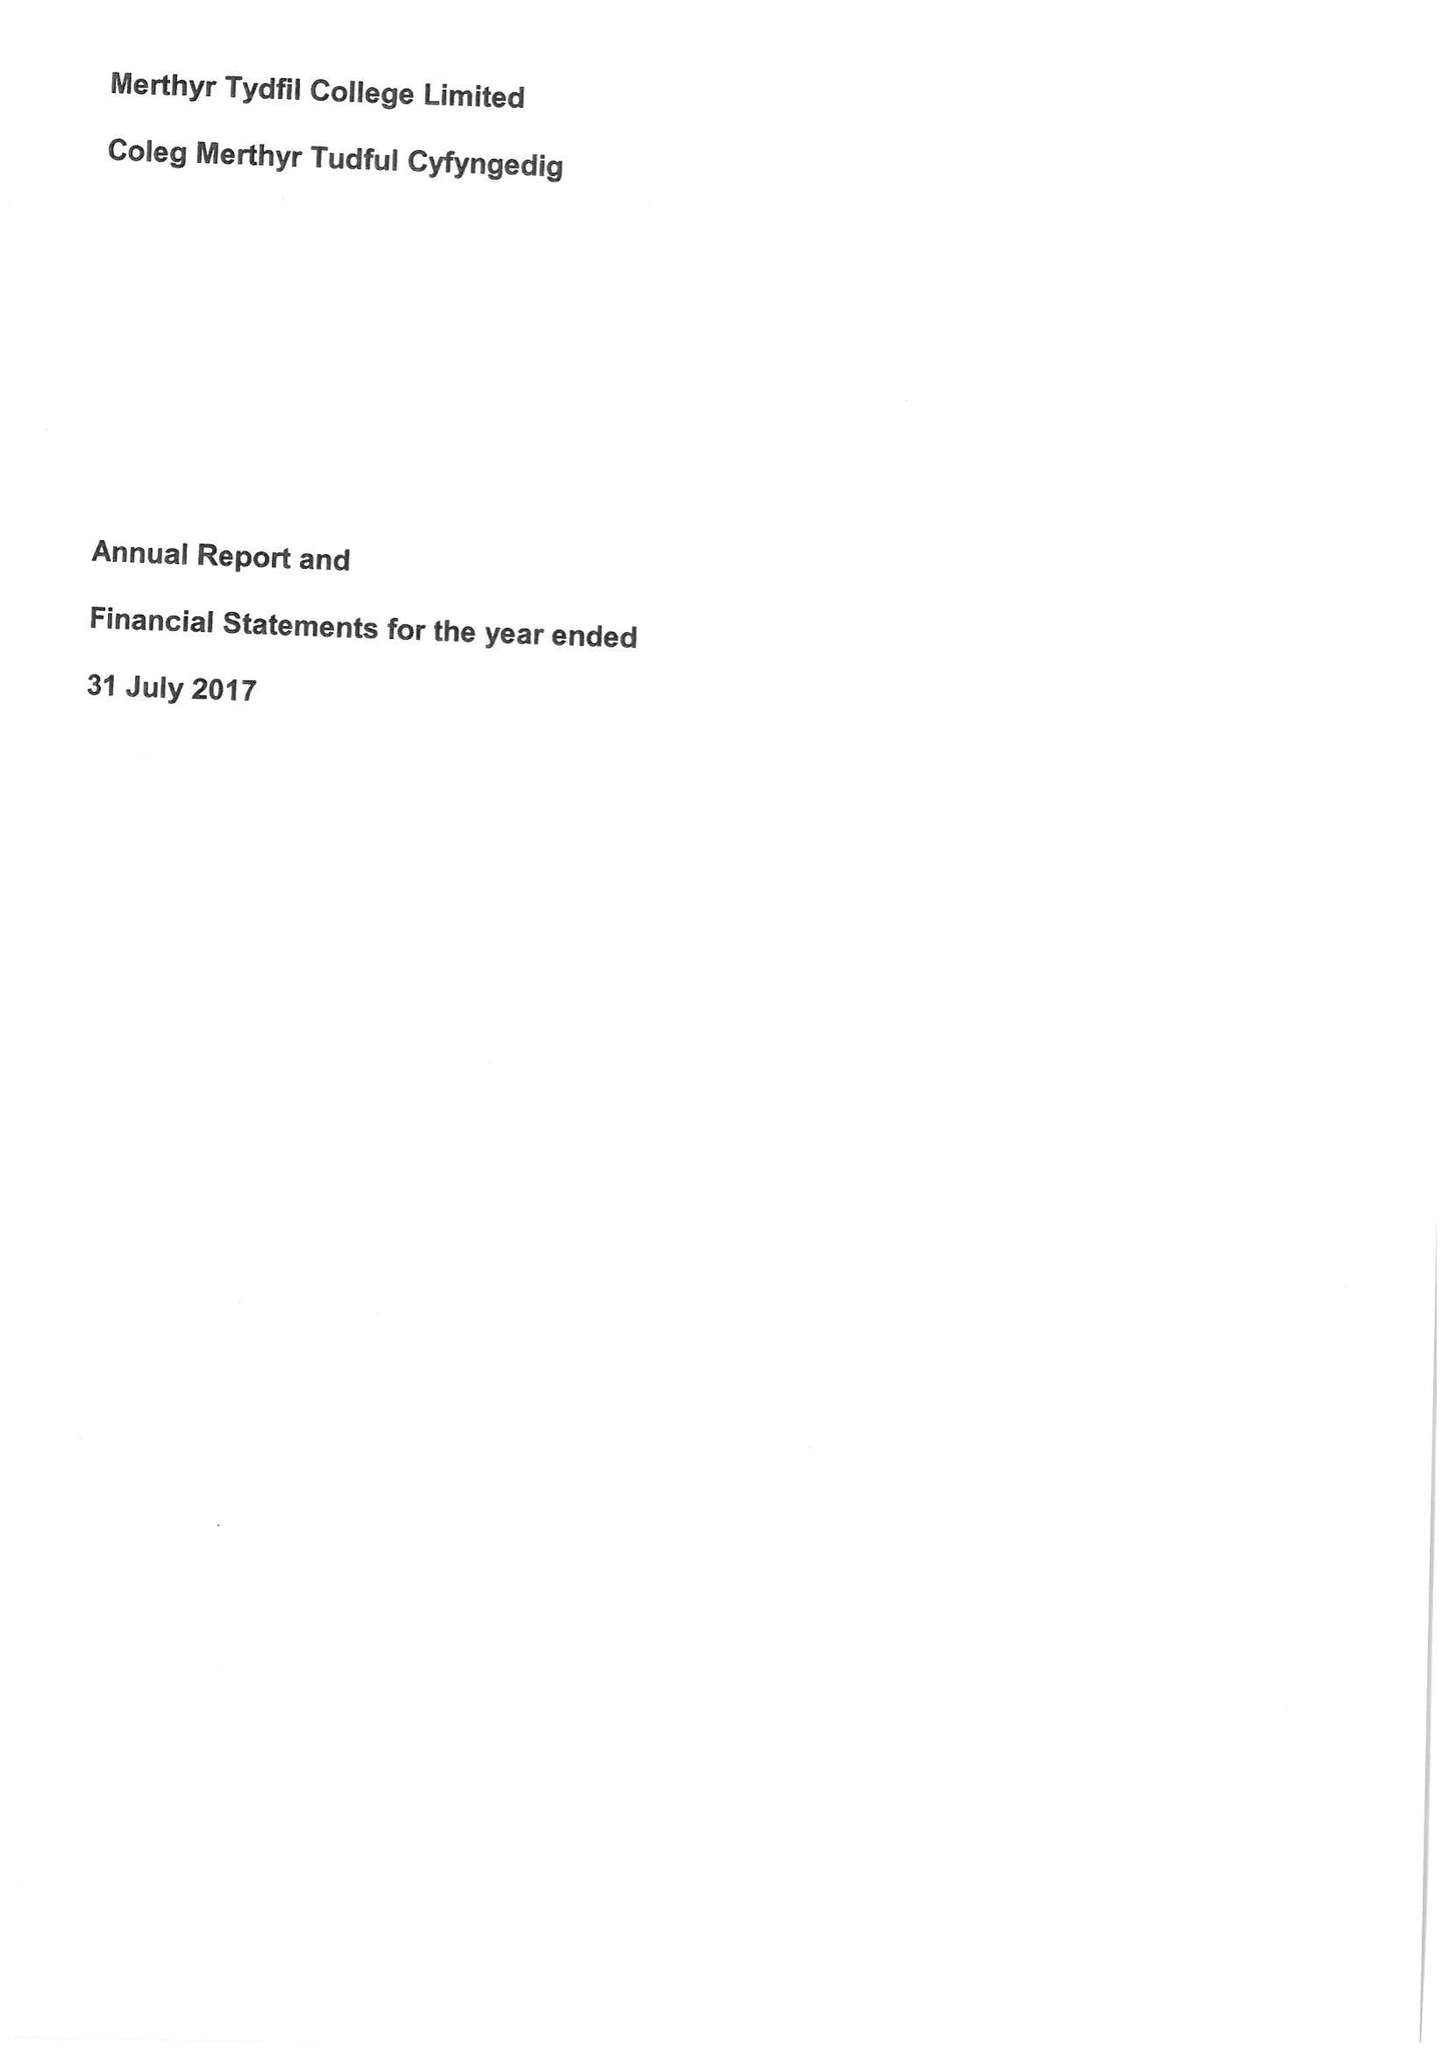What is the value for the address__postcode?
Answer the question using a single word or phrase. CF37 1DL 